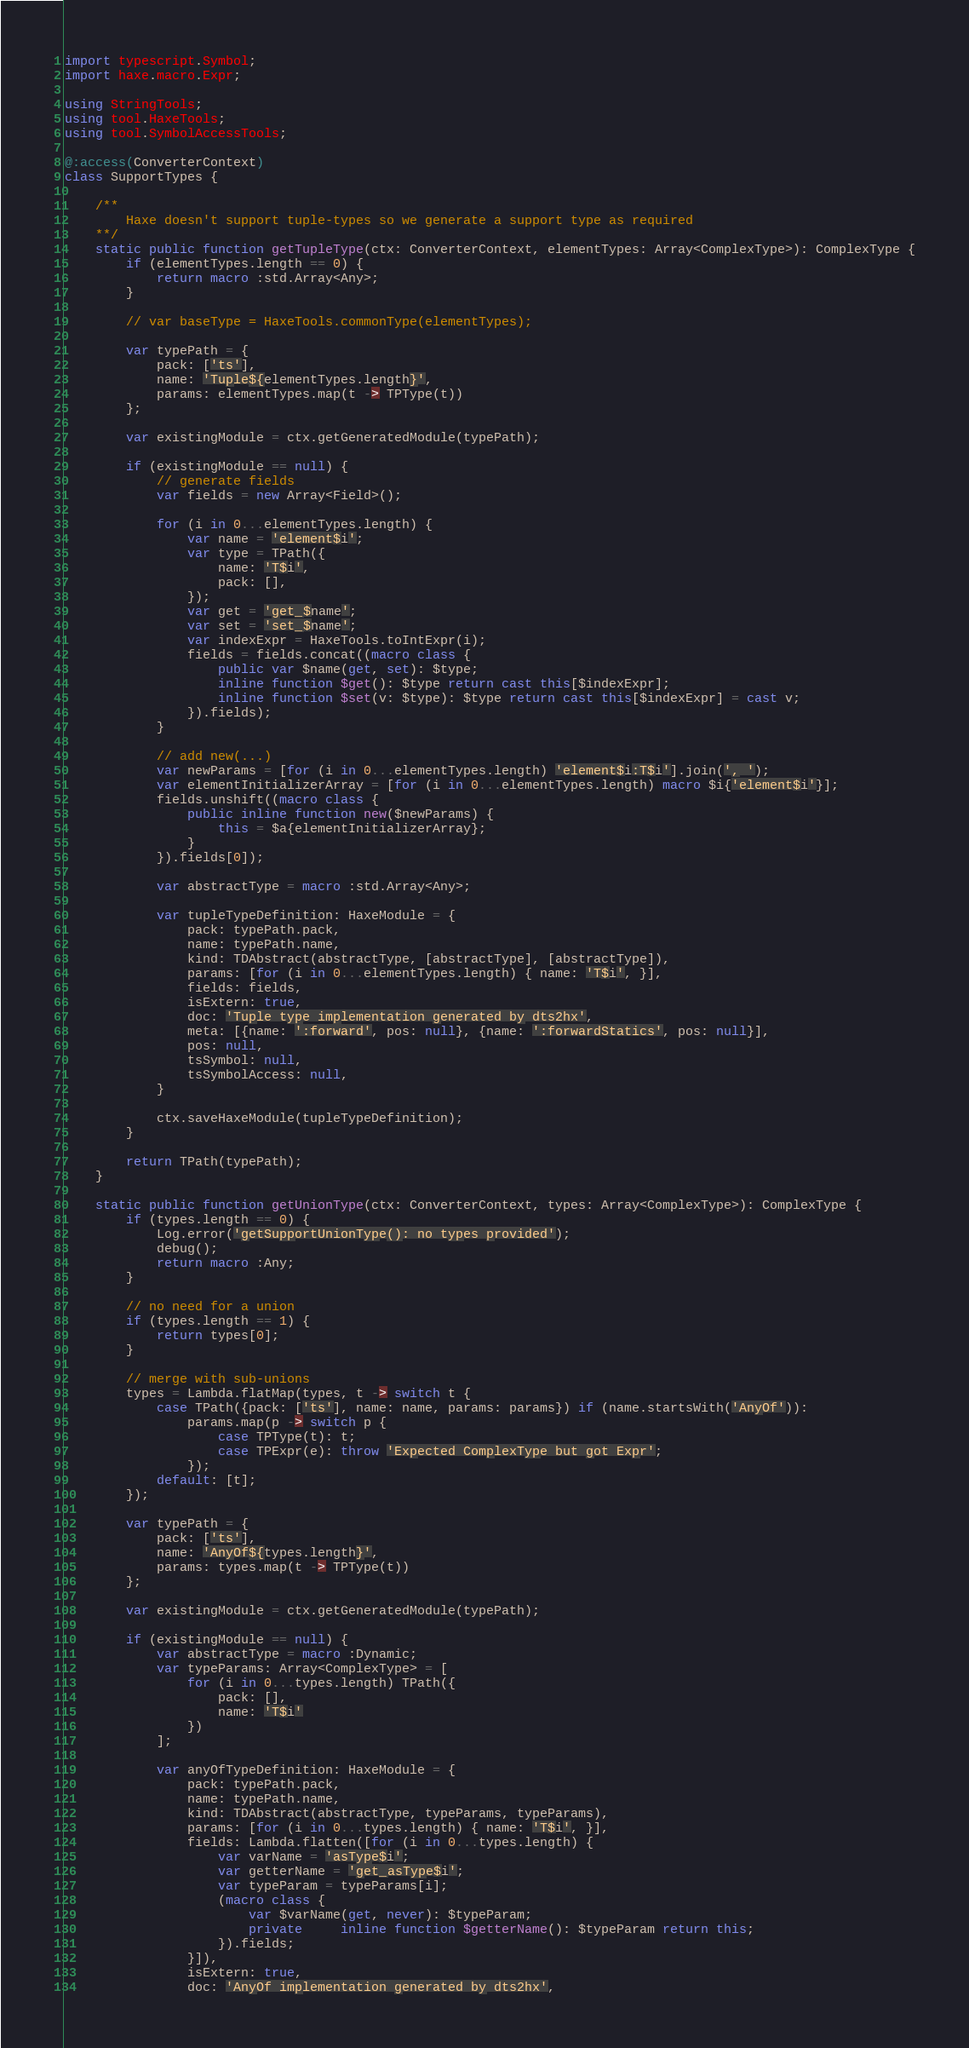<code> <loc_0><loc_0><loc_500><loc_500><_Haxe_>import typescript.Symbol;
import haxe.macro.Expr;

using StringTools;
using tool.HaxeTools;
using tool.SymbolAccessTools;

@:access(ConverterContext)
class SupportTypes {

	/**
		Haxe doesn't support tuple-types so we generate a support type as required
	**/
	static public function getTupleType(ctx: ConverterContext, elementTypes: Array<ComplexType>): ComplexType {
		if (elementTypes.length == 0) {
			return macro :std.Array<Any>;
		}

		// var baseType = HaxeTools.commonType(elementTypes);

		var typePath = {
			pack: ['ts'],
			name: 'Tuple${elementTypes.length}',
			params: elementTypes.map(t -> TPType(t))
		};

		var existingModule = ctx.getGeneratedModule(typePath);

		if (existingModule == null) {
			// generate fields
			var fields = new Array<Field>();

			for (i in 0...elementTypes.length) {
				var name = 'element$i';
				var type = TPath({
					name: 'T$i',
					pack: [],
				});
				var get = 'get_$name';
				var set = 'set_$name';
				var indexExpr = HaxeTools.toIntExpr(i);
				fields = fields.concat((macro class {
					public var $name(get, set): $type;
					inline function $get(): $type return cast this[$indexExpr];
					inline function $set(v: $type): $type return cast this[$indexExpr] = cast v;
				}).fields);
			}

			// add new(...)
			var newParams = [for (i in 0...elementTypes.length) 'element$i:T$i'].join(', ');
			var elementInitializerArray = [for (i in 0...elementTypes.length) macro $i{'element$i'}];
			fields.unshift((macro class {
				public inline function new($newParams) {
					this = $a{elementInitializerArray};
				}
			}).fields[0]);

			var abstractType = macro :std.Array<Any>;

			var tupleTypeDefinition: HaxeModule = {
				pack: typePath.pack,
				name: typePath.name,
				kind: TDAbstract(abstractType, [abstractType], [abstractType]),
				params: [for (i in 0...elementTypes.length) { name: 'T$i', }],
				fields: fields,
				isExtern: true,
				doc: 'Tuple type implementation generated by dts2hx',
				meta: [{name: ':forward', pos: null}, {name: ':forwardStatics', pos: null}],
				pos: null,
				tsSymbol: null,
				tsSymbolAccess: null,
			}

			ctx.saveHaxeModule(tupleTypeDefinition);
		}

		return TPath(typePath);
	}

	static public function getUnionType(ctx: ConverterContext, types: Array<ComplexType>): ComplexType {
		if (types.length == 0) {
			Log.error('getSupportUnionType(): no types provided');
			debug();
			return macro :Any;
		}

		// no need for a union
		if (types.length == 1) {
			return types[0];
		}

		// merge with sub-unions
		types = Lambda.flatMap(types, t -> switch t {
			case TPath({pack: ['ts'], name: name, params: params}) if (name.startsWith('AnyOf')):
				params.map(p -> switch p {
					case TPType(t): t;
					case TPExpr(e): throw 'Expected ComplexType but got Expr';
				});
			default: [t];
		});

		var typePath = {
			pack: ['ts'],
			name: 'AnyOf${types.length}',
			params: types.map(t -> TPType(t))
		};

		var existingModule = ctx.getGeneratedModule(typePath);

		if (existingModule == null) {
			var abstractType = macro :Dynamic;
			var typeParams: Array<ComplexType> = [
				for (i in 0...types.length) TPath({
					pack: [],
					name: 'T$i'
				})
			];

			var anyOfTypeDefinition: HaxeModule = {
				pack: typePath.pack,
				name: typePath.name,
				kind: TDAbstract(abstractType, typeParams, typeParams),
				params: [for (i in 0...types.length) { name: 'T$i', }],
				fields: Lambda.flatten([for (i in 0...types.length) {
					var varName = 'asType$i';
					var getterName = 'get_asType$i';
					var typeParam = typeParams[i];
					(macro class {
						var $varName(get, never): $typeParam;
						private	 inline function $getterName(): $typeParam return this;
					}).fields;
				}]),
				isExtern: true,
				doc: 'AnyOf implementation generated by dts2hx',</code> 